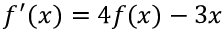Convert formula to latex. <formula><loc_0><loc_0><loc_500><loc_500>f ^ { \prime } ( x ) = 4 f ( x ) - 3 x</formula> 